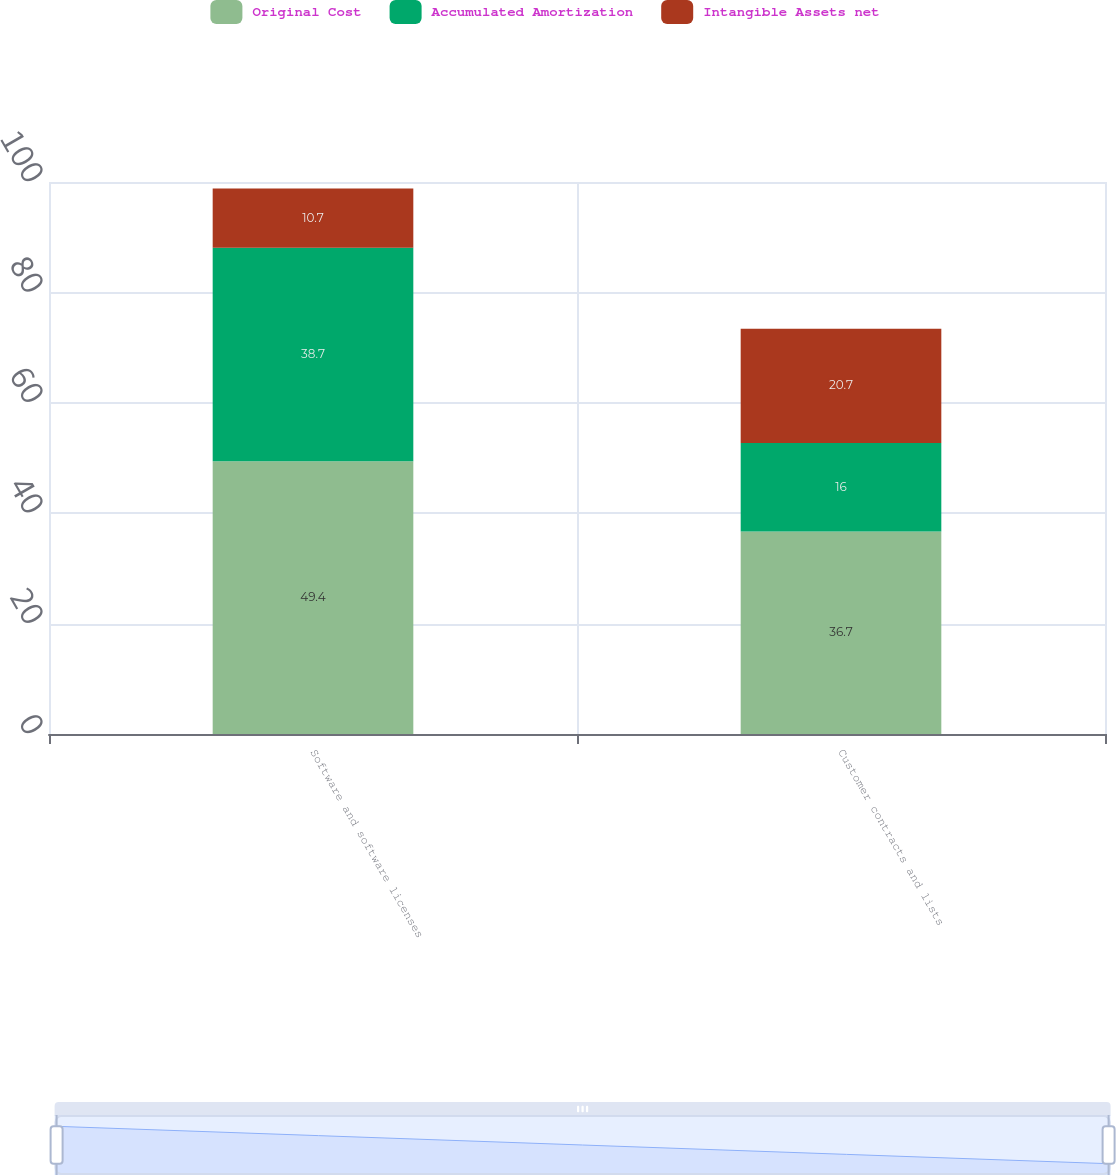Convert chart. <chart><loc_0><loc_0><loc_500><loc_500><stacked_bar_chart><ecel><fcel>Software and software licenses<fcel>Customer contracts and lists<nl><fcel>Original Cost<fcel>49.4<fcel>36.7<nl><fcel>Accumulated Amortization<fcel>38.7<fcel>16<nl><fcel>Intangible Assets net<fcel>10.7<fcel>20.7<nl></chart> 